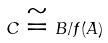<formula> <loc_0><loc_0><loc_500><loc_500>C \cong B / f ( A )</formula> 